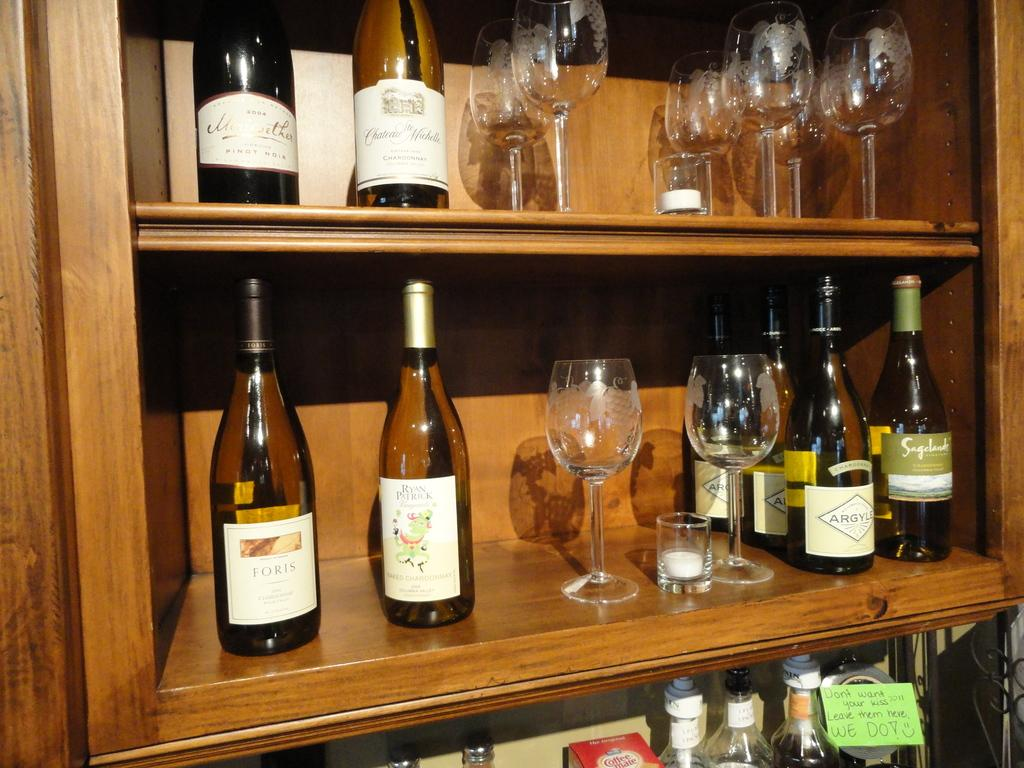<image>
Describe the image concisely. A great mix of different wines including Foris and some wine glasses 